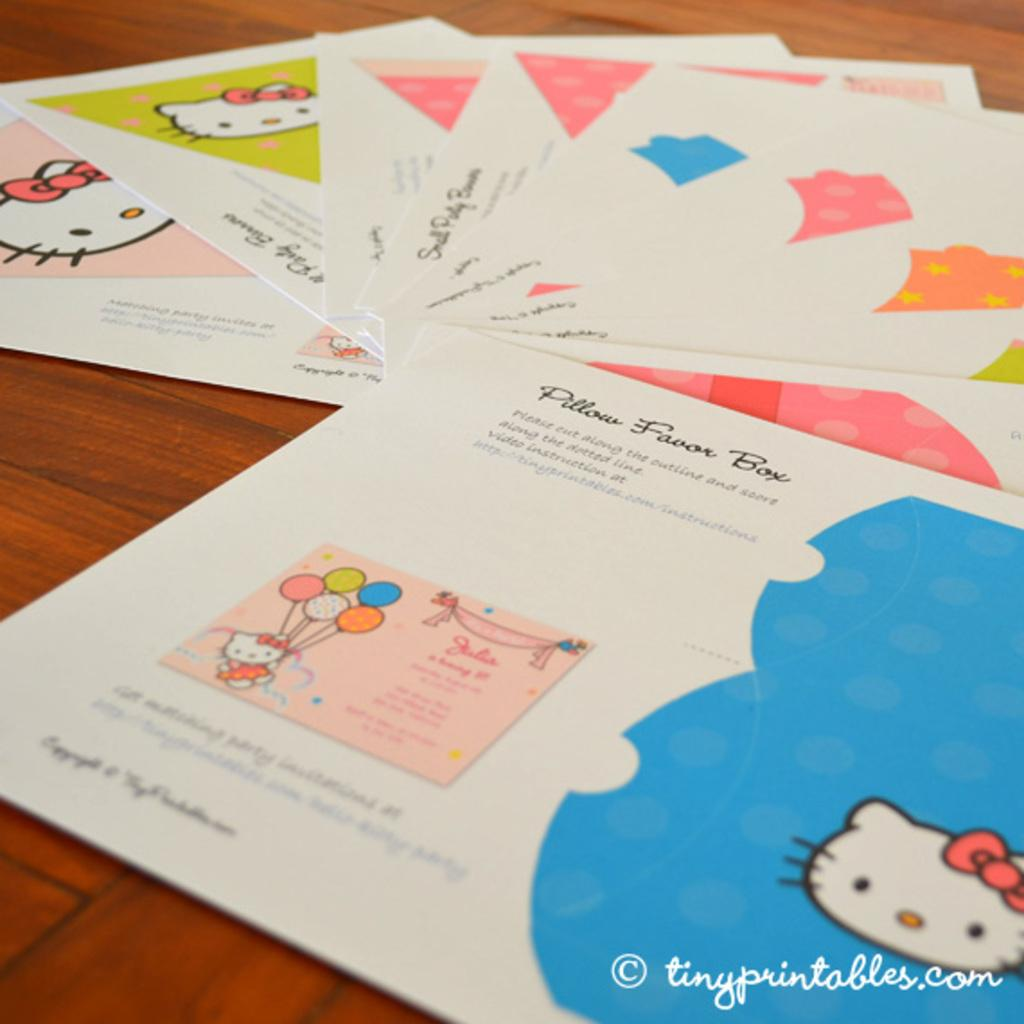Provide a one-sentence caption for the provided image. A set of Hello Kitty party favors with the text "Pillow Favor Box" written on the top. 